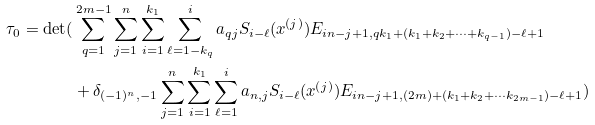Convert formula to latex. <formula><loc_0><loc_0><loc_500><loc_500>\tau _ { 0 } = \det ( & \sum _ { q = 1 } ^ { 2 m - 1 } \sum _ { j = 1 } ^ { n } \sum _ { i = 1 } ^ { k _ { 1 } } \sum _ { \ell = 1 - k _ { q } } ^ { i } a _ { q j } S _ { i - \ell } ( x ^ { ( j ) } ) E _ { i n - j + 1 , q k _ { 1 } + ( k _ { 1 } + k _ { 2 } + \cdots + k _ { q - 1 } ) - \ell + 1 } \\ \ & + \delta _ { ( - 1 ) ^ { n } , - 1 } \sum _ { j = 1 } ^ { n } \sum _ { i = 1 } ^ { k _ { 1 } } \sum _ { \ell = 1 } ^ { i } a _ { n , j } S _ { i - \ell } ( x ^ { ( j ) } ) E _ { i n - j + 1 , ( 2 m ) + ( k _ { 1 } + k _ { 2 } + \cdots k _ { 2 m - 1 } ) - \ell + 1 } ) \\</formula> 